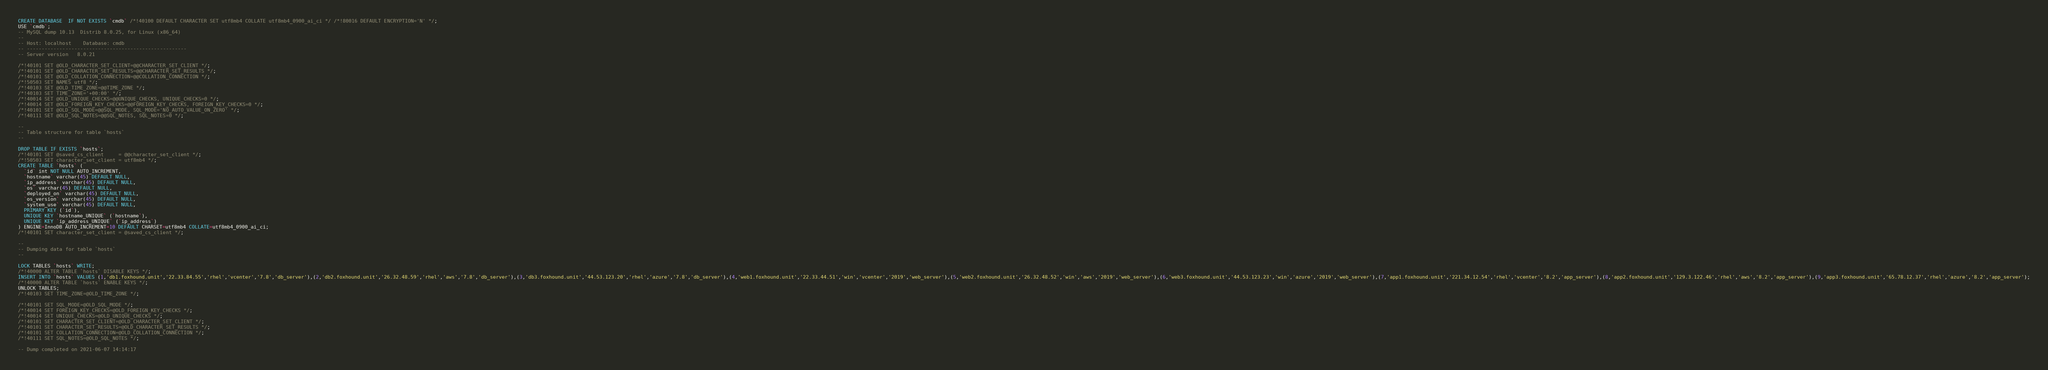<code> <loc_0><loc_0><loc_500><loc_500><_SQL_>CREATE DATABASE  IF NOT EXISTS `cmdb` /*!40100 DEFAULT CHARACTER SET utf8mb4 COLLATE utf8mb4_0900_ai_ci */ /*!80016 DEFAULT ENCRYPTION='N' */;
USE `cmdb`;
-- MySQL dump 10.13  Distrib 8.0.25, for Linux (x86_64)
--
-- Host: localhost    Database: cmdb
-- ------------------------------------------------------
-- Server version	8.0.21

/*!40101 SET @OLD_CHARACTER_SET_CLIENT=@@CHARACTER_SET_CLIENT */;
/*!40101 SET @OLD_CHARACTER_SET_RESULTS=@@CHARACTER_SET_RESULTS */;
/*!40101 SET @OLD_COLLATION_CONNECTION=@@COLLATION_CONNECTION */;
/*!50503 SET NAMES utf8 */;
/*!40103 SET @OLD_TIME_ZONE=@@TIME_ZONE */;
/*!40103 SET TIME_ZONE='+00:00' */;
/*!40014 SET @OLD_UNIQUE_CHECKS=@@UNIQUE_CHECKS, UNIQUE_CHECKS=0 */;
/*!40014 SET @OLD_FOREIGN_KEY_CHECKS=@@FOREIGN_KEY_CHECKS, FOREIGN_KEY_CHECKS=0 */;
/*!40101 SET @OLD_SQL_MODE=@@SQL_MODE, SQL_MODE='NO_AUTO_VALUE_ON_ZERO' */;
/*!40111 SET @OLD_SQL_NOTES=@@SQL_NOTES, SQL_NOTES=0 */;

--
-- Table structure for table `hosts`
--

DROP TABLE IF EXISTS `hosts`;
/*!40101 SET @saved_cs_client     = @@character_set_client */;
/*!50503 SET character_set_client = utf8mb4 */;
CREATE TABLE `hosts` (
  `id` int NOT NULL AUTO_INCREMENT,
  `hostname` varchar(45) DEFAULT NULL,
  `ip_address` varchar(45) DEFAULT NULL,
  `os` varchar(45) DEFAULT NULL,
  `deployed_on` varchar(45) DEFAULT NULL,
  `os_version` varchar(45) DEFAULT NULL,
  `system_use` varchar(45) DEFAULT NULL,
  PRIMARY KEY (`id`),
  UNIQUE KEY `hostname_UNIQUE` (`hostname`),
  UNIQUE KEY `ip_address_UNIQUE` (`ip_address`)
) ENGINE=InnoDB AUTO_INCREMENT=10 DEFAULT CHARSET=utf8mb4 COLLATE=utf8mb4_0900_ai_ci;
/*!40101 SET character_set_client = @saved_cs_client */;

--
-- Dumping data for table `hosts`
--

LOCK TABLES `hosts` WRITE;
/*!40000 ALTER TABLE `hosts` DISABLE KEYS */;
INSERT INTO `hosts` VALUES (1,'db1.foxhound.unit','22.33.84.55','rhel','vcenter','7.8','db_server'),(2,'db2.foxhound.unit','26.32.48.59','rhel','aws','7.8','db_server'),(3,'db3.foxhound.unit','44.53.123.20','rhel','azure','7.8','db_server'),(4,'web1.foxhound.unit','22.33.44.51','win','vcenter','2019','web_server'),(5,'web2.foxhound.unit','26.32.48.52','win','aws','2019','web_server'),(6,'web3.foxhound.unit','44.53.123.23','win','azure','2019','web_server'),(7,'app1.foxhound.unit','221.34.12.54','rhel','vcenter','8.2','app_server'),(8,'app2.foxhound.unit','129.3.122.46','rhel','aws','8.2','app_server'),(9,'app3.foxhound.unit','65.78.12.37','rhel','azure','8.2','app_server');
/*!40000 ALTER TABLE `hosts` ENABLE KEYS */;
UNLOCK TABLES;
/*!40103 SET TIME_ZONE=@OLD_TIME_ZONE */;

/*!40101 SET SQL_MODE=@OLD_SQL_MODE */;
/*!40014 SET FOREIGN_KEY_CHECKS=@OLD_FOREIGN_KEY_CHECKS */;
/*!40014 SET UNIQUE_CHECKS=@OLD_UNIQUE_CHECKS */;
/*!40101 SET CHARACTER_SET_CLIENT=@OLD_CHARACTER_SET_CLIENT */;
/*!40101 SET CHARACTER_SET_RESULTS=@OLD_CHARACTER_SET_RESULTS */;
/*!40101 SET COLLATION_CONNECTION=@OLD_COLLATION_CONNECTION */;
/*!40111 SET SQL_NOTES=@OLD_SQL_NOTES */;

-- Dump completed on 2021-06-07 14:14:17
</code> 